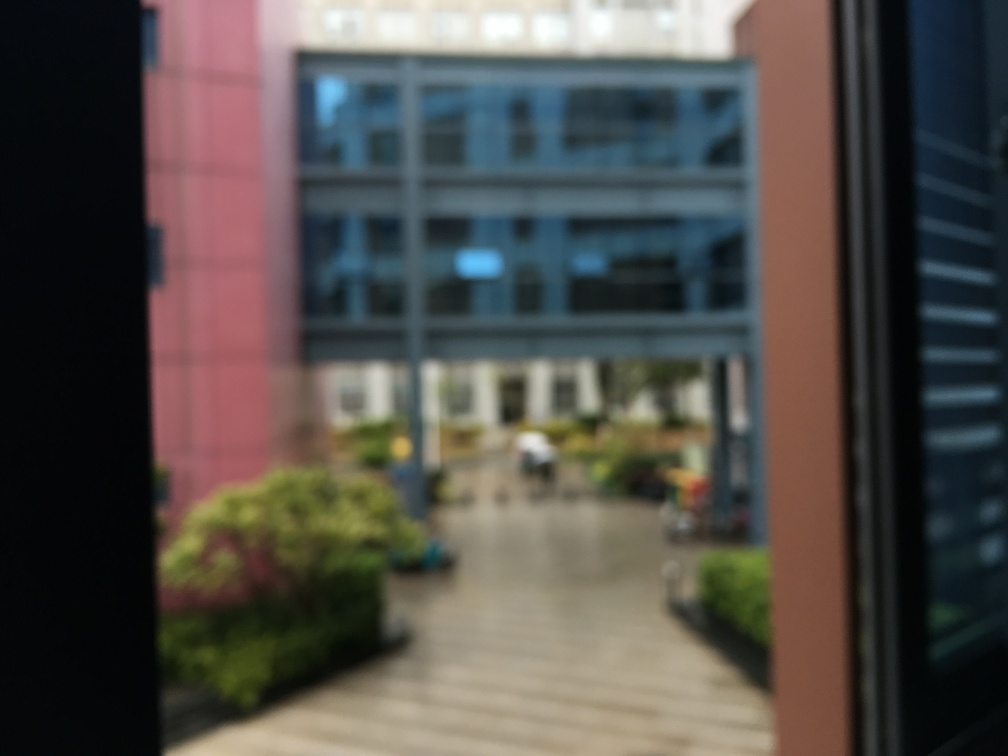Are there any people or objects that stand out in this image? Due to the significant blurring of the image, it's difficult to make out specific details about people or objects. However, there may be a person or a small group of individuals in the center-ground of the image, indicating some activity in the area. 